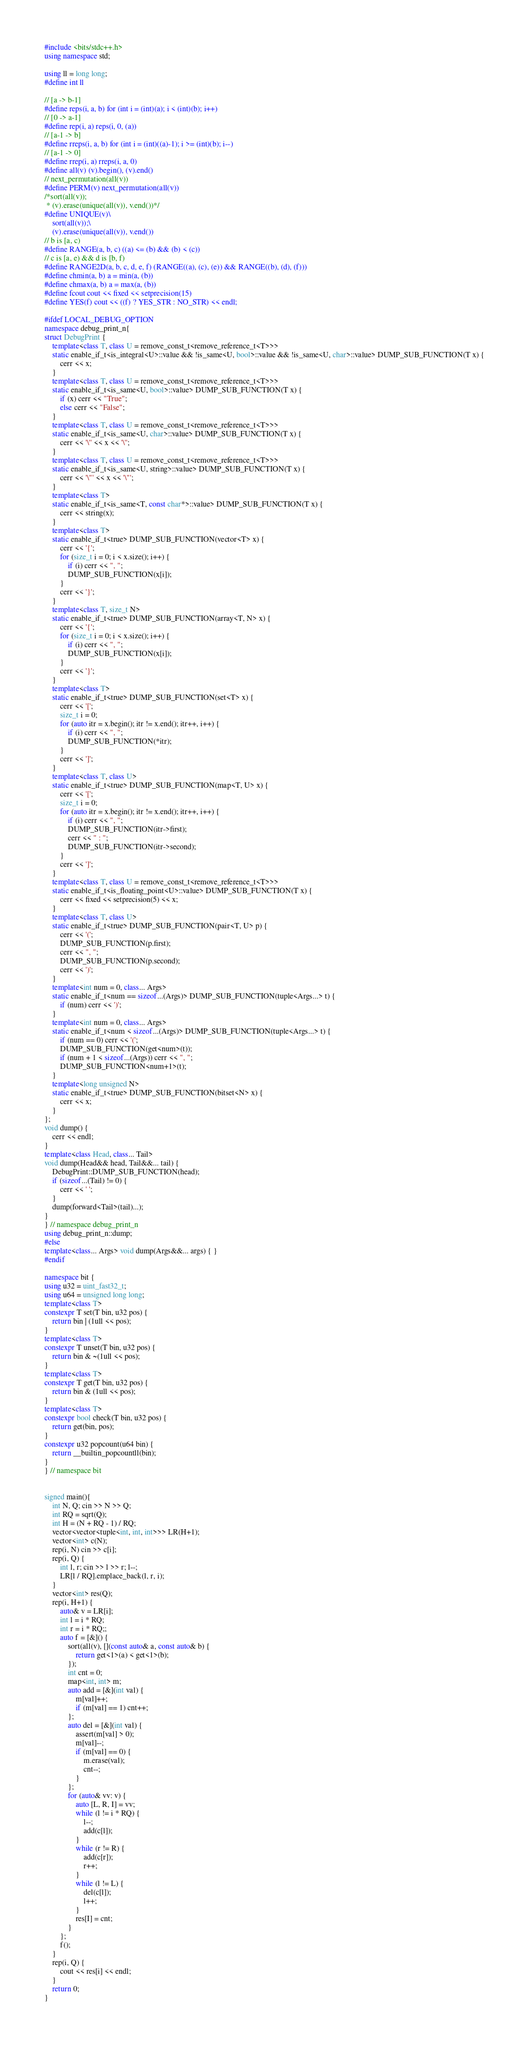<code> <loc_0><loc_0><loc_500><loc_500><_C++_>#include <bits/stdc++.h>
using namespace std;

using ll = long long;
#define int ll

// [a -> b-1]
#define reps(i, a, b) for (int i = (int)(a); i < (int)(b); i++)
// [0 -> a-1]
#define rep(i, a) reps(i, 0, (a))
// [a-1 -> b]
#define rreps(i, a, b) for (int i = (int)((a)-1); i >= (int)(b); i--)
// [a-1 -> 0]
#define rrep(i, a) rreps(i, a, 0)
#define all(v) (v).begin(), (v).end()
// next_permutation(all(v))
#define PERM(v) next_permutation(all(v))
/*sort(all(v));
 * (v).erase(unique(all(v)), v.end())*/
#define UNIQUE(v)\
	sort(all(v));\
	(v).erase(unique(all(v)), v.end())
// b is [a, c)
#define RANGE(a, b, c) ((a) <= (b) && (b) < (c))
// c is [a, e) && d is [b, f)
#define RANGE2D(a, b, c, d, e, f) (RANGE((a), (c), (e)) && RANGE((b), (d), (f)))
#define chmin(a, b) a = min(a, (b))
#define chmax(a, b) a = max(a, (b))
#define fcout cout << fixed << setprecision(15)
#define YES(f) cout << ((f) ? YES_STR : NO_STR) << endl;

#ifdef LOCAL_DEBUG_OPTION
namespace debug_print_n{
struct DebugPrint {
	template<class T, class U = remove_const_t<remove_reference_t<T>>>
	static enable_if_t<is_integral<U>::value && !is_same<U, bool>::value && !is_same<U, char>::value> DUMP_SUB_FUNCTION(T x) {
		cerr << x;
	}
	template<class T, class U = remove_const_t<remove_reference_t<T>>>
	static enable_if_t<is_same<U, bool>::value> DUMP_SUB_FUNCTION(T x) {
		if (x) cerr << "True";
		else cerr << "False";
	}
	template<class T, class U = remove_const_t<remove_reference_t<T>>>
	static enable_if_t<is_same<U, char>::value> DUMP_SUB_FUNCTION(T x) {
		cerr << '\'' << x << '\'';
	}
	template<class T, class U = remove_const_t<remove_reference_t<T>>>
	static enable_if_t<is_same<U, string>::value> DUMP_SUB_FUNCTION(T x) {
		cerr << '\"' << x << '\"';
	}
	template<class T>
	static enable_if_t<is_same<T, const char*>::value> DUMP_SUB_FUNCTION(T x) {
		cerr << string(x);
	}
	template<class T>
	static enable_if_t<true> DUMP_SUB_FUNCTION(vector<T> x) {
		cerr << '{';
		for (size_t i = 0; i < x.size(); i++) {
			if (i) cerr << ", ";
			DUMP_SUB_FUNCTION(x[i]);
		}
		cerr << '}';
	}
	template<class T, size_t N>
	static enable_if_t<true> DUMP_SUB_FUNCTION(array<T, N> x) {
		cerr << '{';
		for (size_t i = 0; i < x.size(); i++) {
			if (i) cerr << ", ";
			DUMP_SUB_FUNCTION(x[i]);
		}
		cerr << '}';
	}
	template<class T>
	static enable_if_t<true> DUMP_SUB_FUNCTION(set<T> x) {
		cerr << '[';
		size_t i = 0;
		for (auto itr = x.begin(); itr != x.end(); itr++, i++) {
			if (i) cerr << ", ";
			DUMP_SUB_FUNCTION(*itr);
		}
		cerr << ']';
	}
	template<class T, class U>
	static enable_if_t<true> DUMP_SUB_FUNCTION(map<T, U> x) {
		cerr << '[';
		size_t i = 0;
		for (auto itr = x.begin(); itr != x.end(); itr++, i++) {
			if (i) cerr << ", ";
			DUMP_SUB_FUNCTION(itr->first);
			cerr << " : ";
			DUMP_SUB_FUNCTION(itr->second);
		}
		cerr << ']';
	}
	template<class T, class U = remove_const_t<remove_reference_t<T>>>
	static enable_if_t<is_floating_point<U>::value> DUMP_SUB_FUNCTION(T x) {
		cerr << fixed << setprecision(5) << x;
	}
	template<class T, class U>
	static enable_if_t<true> DUMP_SUB_FUNCTION(pair<T, U> p) {
		cerr << '(';
		DUMP_SUB_FUNCTION(p.first);
		cerr << ", ";
		DUMP_SUB_FUNCTION(p.second);
		cerr << ')';
	}
	template<int num = 0, class... Args>
	static enable_if_t<num == sizeof...(Args)> DUMP_SUB_FUNCTION(tuple<Args...> t) {
		if (num) cerr << ')';
	}
	template<int num = 0, class... Args>
	static enable_if_t<num < sizeof...(Args)> DUMP_SUB_FUNCTION(tuple<Args...> t) {
		if (num == 0) cerr << '(';
		DUMP_SUB_FUNCTION(get<num>(t));
		if (num + 1 < sizeof...(Args)) cerr << ", ";
		DUMP_SUB_FUNCTION<num+1>(t);
	}
	template<long unsigned N>
	static enable_if_t<true> DUMP_SUB_FUNCTION(bitset<N> x) {
		cerr << x;
	}
};
void dump() {
	cerr << endl;
}
template<class Head, class... Tail>
void dump(Head&& head, Tail&&... tail) {
	DebugPrint::DUMP_SUB_FUNCTION(head);
	if (sizeof...(Tail) != 0) {
		cerr << ' ';
	}
	dump(forward<Tail>(tail)...);
}
} // namespace debug_print_n
using debug_print_n::dump;
#else
template<class... Args> void dump(Args&&... args) { }
#endif

namespace bit {
using u32 = uint_fast32_t;
using u64 = unsigned long long;
template<class T>
constexpr T set(T bin, u32 pos) {
	return bin | (1ull << pos);
}
template<class T>
constexpr T unset(T bin, u32 pos) {
	return bin & ~(1ull << pos);
}
template<class T>
constexpr T get(T bin, u32 pos) {
	return bin & (1ull << pos);
}
template<class T>
constexpr bool check(T bin, u32 pos) {
	return get(bin, pos);
}
constexpr u32 popcount(u64 bin) {
	return __builtin_popcountll(bin);
}
} // namespace bit


signed main(){
	int N, Q; cin >> N >> Q;
	int RQ = sqrt(Q);
	int H = (N + RQ - 1) / RQ;
	vector<vector<tuple<int, int, int>>> LR(H+1);
	vector<int> c(N);
	rep(i, N) cin >> c[i];
	rep(i, Q) {
		int l, r; cin >> l >> r; l--;
		LR[l / RQ].emplace_back(l, r, i);
	}
	vector<int> res(Q);
	rep(i, H+1) {
		auto& v = LR[i];
		int l = i * RQ;
		int r = i * RQ;;
		auto f = [&]() {
			sort(all(v), [](const auto& a, const auto& b) {
				return get<1>(a) < get<1>(b);
			});
			int cnt = 0;
			map<int, int> m;
			auto add = [&](int val) {
				m[val]++;
				if (m[val] == 1) cnt++;
			};
			auto del = [&](int val) {
				assert(m[val] > 0);
				m[val]--;
				if (m[val] == 0) {
					m.erase(val);
					cnt--;
				}
			};
			for (auto& vv: v) {
				auto [L, R, I] = vv;
				while (l != i * RQ) {
					l--;
					add(c[l]);
				}
				while (r != R) {
					add(c[r]);
					r++;
				}
				while (l != L) {
					del(c[l]);
					l++;
				}
				res[I] = cnt;
			}
		};
		f();
	}
	rep(i, Q) {
		cout << res[i] << endl;
	}
	return 0;
}
</code> 